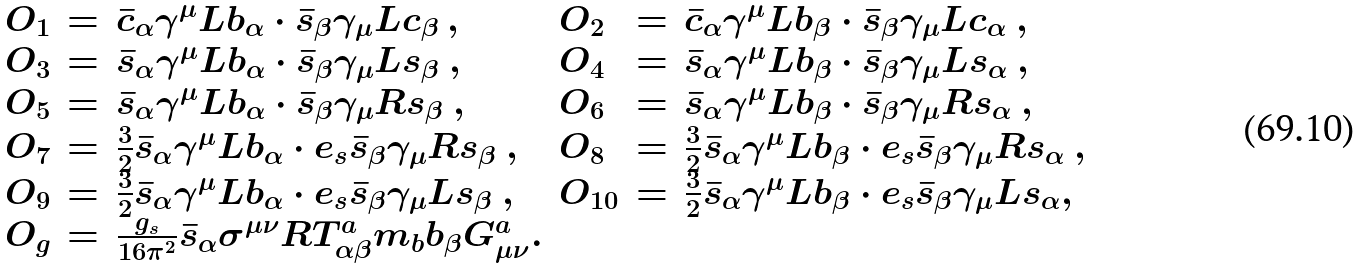<formula> <loc_0><loc_0><loc_500><loc_500>\begin{array} { l l l l l l } O _ { 1 } & = & \bar { c } _ { \alpha } \gamma ^ { \mu } L b _ { \alpha } \cdot \bar { s } _ { \beta } \gamma _ { \mu } L c _ { \beta } \ , & O _ { 2 } & = & \bar { c } _ { \alpha } \gamma ^ { \mu } L b _ { \beta } \cdot \bar { s } _ { \beta } \gamma _ { \mu } L c _ { \alpha } \ , \\ O _ { 3 } & = & \bar { s } _ { \alpha } \gamma ^ { \mu } L b _ { \alpha } \cdot \bar { s } _ { \beta } \gamma _ { \mu } L s _ { \beta } \ , & O _ { 4 } & = & \bar { s } _ { \alpha } \gamma ^ { \mu } L b _ { \beta } \cdot \bar { s } _ { \beta } \gamma _ { \mu } L s _ { \alpha } \ , \\ O _ { 5 } & = & \bar { s } _ { \alpha } \gamma ^ { \mu } L b _ { \alpha } \cdot \bar { s } _ { \beta } \gamma _ { \mu } R s _ { \beta } \ , & O _ { 6 } & = & \bar { s } _ { \alpha } \gamma ^ { \mu } L b _ { \beta } \cdot \bar { s } _ { \beta } \gamma _ { \mu } R s _ { \alpha } \ , \\ O _ { 7 } & = & \frac { 3 } { 2 } \bar { s } _ { \alpha } \gamma ^ { \mu } L b _ { \alpha } \cdot e _ { s } \bar { s } _ { \beta } \gamma _ { \mu } R s _ { \beta } \ , & O _ { 8 } & = & \frac { 3 } { 2 } \bar { s } _ { \alpha } \gamma ^ { \mu } L b _ { \beta } \cdot e _ { s } \bar { s } _ { \beta } \gamma _ { \mu } R s _ { \alpha } \ , \\ O _ { 9 } & = & \frac { 3 } { 2 } \bar { s } _ { \alpha } \gamma ^ { \mu } L b _ { \alpha } \cdot e _ { s } \bar { s } _ { \beta } \gamma _ { \mu } L s _ { \beta } \ , & O _ { 1 0 } & = & \frac { 3 } { 2 } \bar { s } _ { \alpha } \gamma ^ { \mu } L b _ { \beta } \cdot e _ { s } \bar { s } _ { \beta } \gamma _ { \mu } L s _ { \alpha } , \\ O _ { g } & = & \frac { g _ { s } } { 1 6 \pi ^ { 2 } } \bar { s } _ { \alpha } \sigma ^ { \mu \nu } R T ^ { a } _ { \alpha \beta } m _ { b } b _ { \beta } G ^ { a } _ { \mu \nu } . & & & \end{array}</formula> 